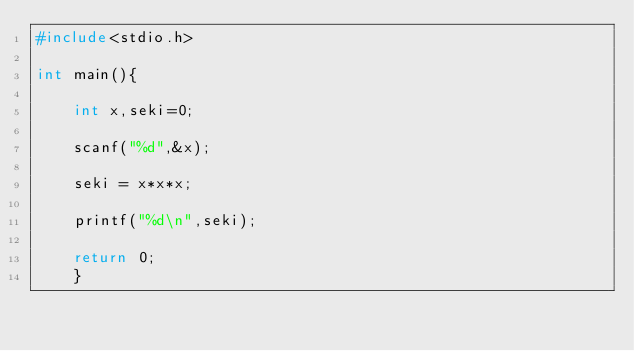Convert code to text. <code><loc_0><loc_0><loc_500><loc_500><_C_>#include<stdio.h>

int main(){

    int x,seki=0;

    scanf("%d",&x);

    seki = x*x*x;

    printf("%d\n",seki);

    return 0;
    }</code> 